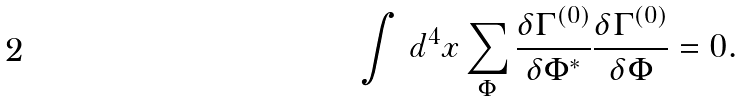<formula> <loc_0><loc_0><loc_500><loc_500>\int \, d ^ { 4 } x \sum _ { \Phi } \frac { \delta \Gamma ^ { ( 0 ) } } { \delta \Phi ^ { * } } \frac { \delta \Gamma ^ { ( 0 ) } } { \delta \Phi } = 0 .</formula> 